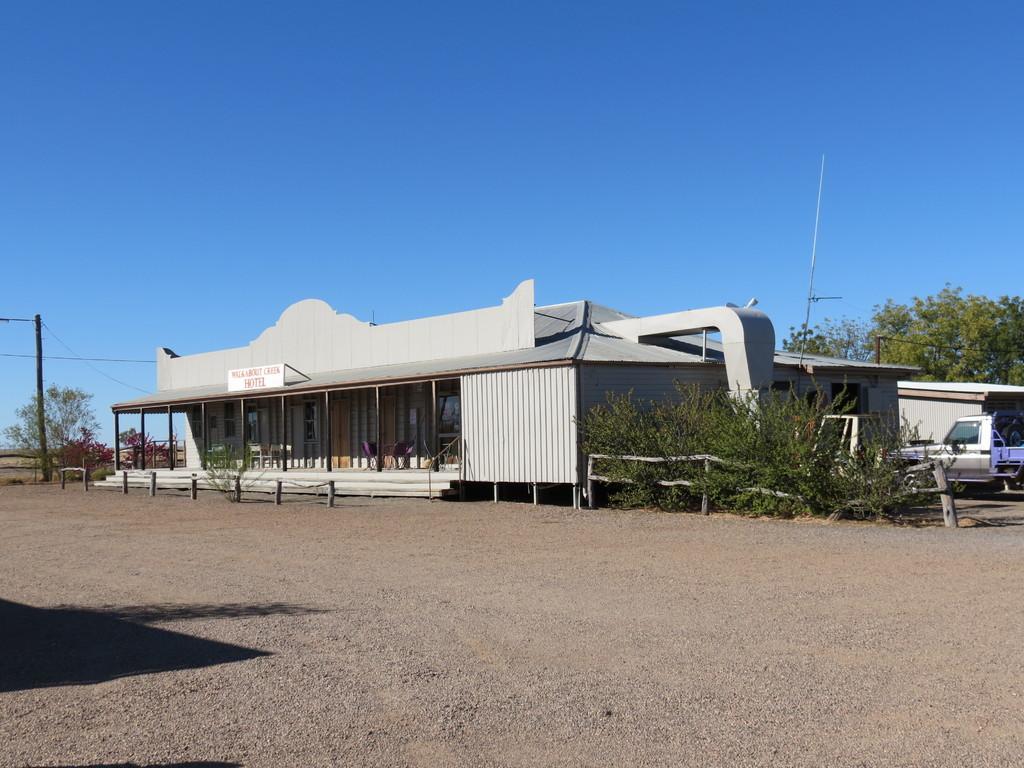In one or two sentences, can you explain what this image depicts? In this image, we can see a shed. There is a pole on the left side of the image. There are some plants and trees on the right side of the image. There is a truck beside the shed. There is a sky at the top of the image. 